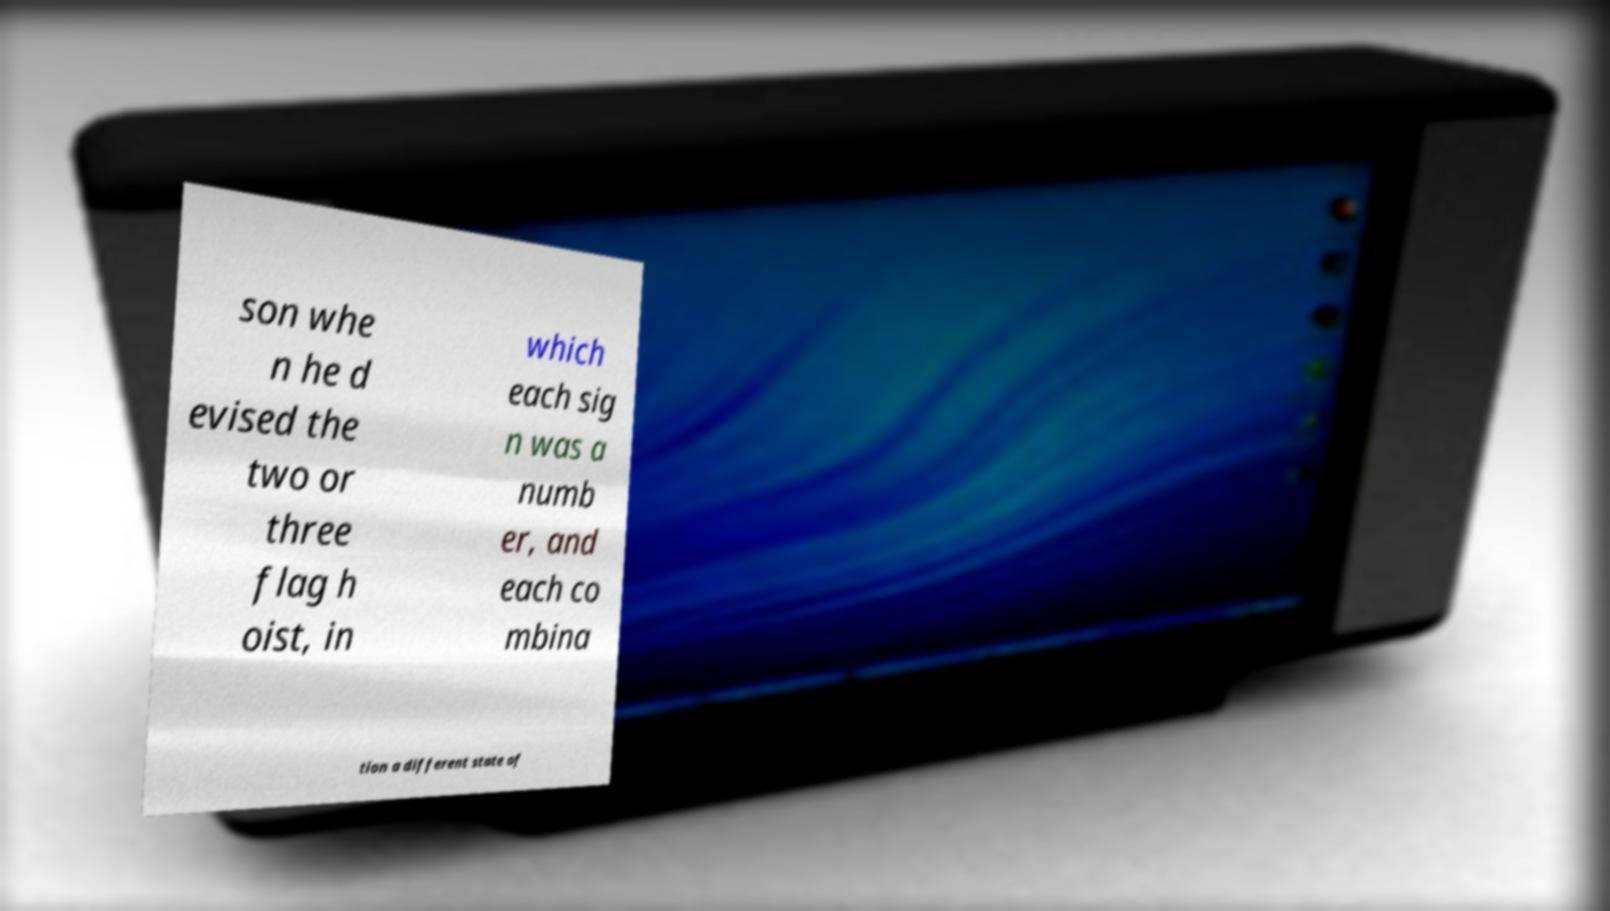I need the written content from this picture converted into text. Can you do that? son whe n he d evised the two or three flag h oist, in which each sig n was a numb er, and each co mbina tion a different state of 